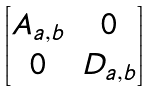Convert formula to latex. <formula><loc_0><loc_0><loc_500><loc_500>\begin{bmatrix} A _ { a , b } & 0 \\ 0 & D _ { a , b } \end{bmatrix}</formula> 